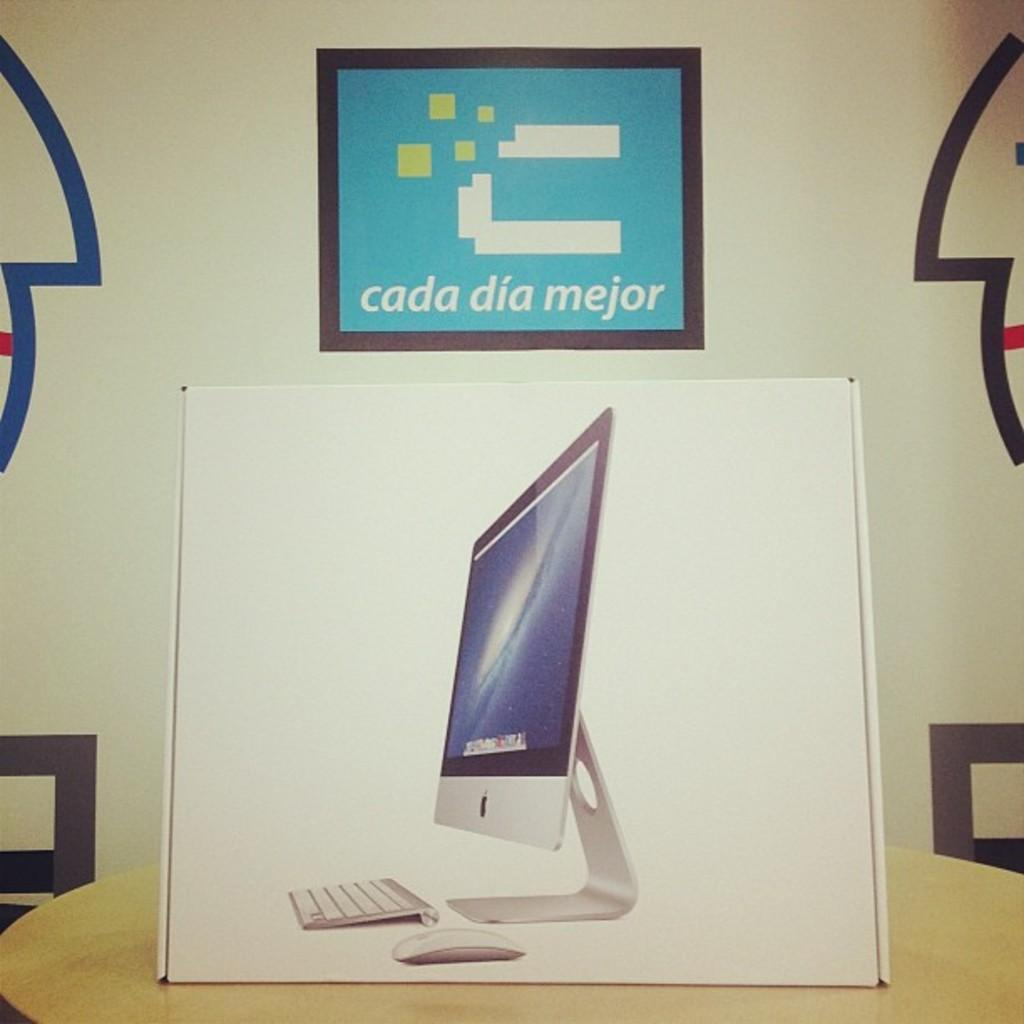Provide a one-sentence caption for the provided image. The sign on the wall says cada dia mejor. 